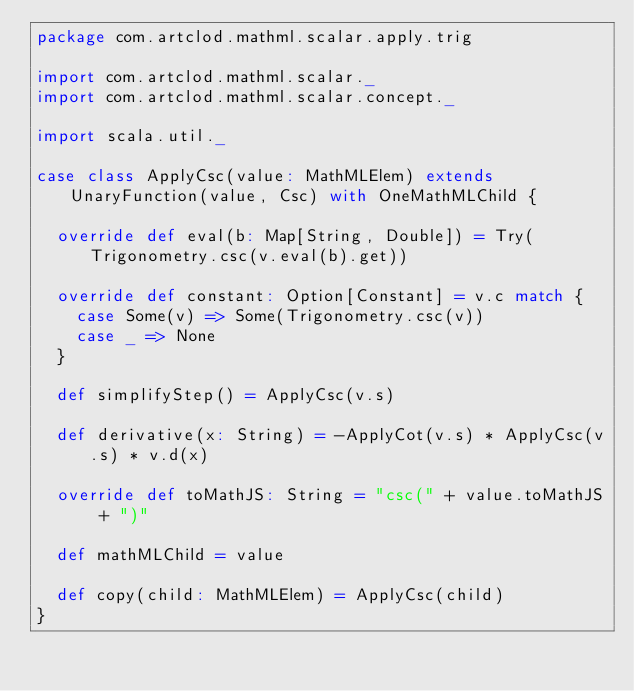Convert code to text. <code><loc_0><loc_0><loc_500><loc_500><_Scala_>package com.artclod.mathml.scalar.apply.trig

import com.artclod.mathml.scalar._
import com.artclod.mathml.scalar.concept._

import scala.util._

case class ApplyCsc(value: MathMLElem) extends UnaryFunction(value, Csc) with OneMathMLChild {

	override def eval(b: Map[String, Double]) = Try(Trigonometry.csc(v.eval(b).get))

	override def constant: Option[Constant] = v.c match {
		case Some(v) => Some(Trigonometry.csc(v))
		case _ => None
	}

	def simplifyStep() = ApplyCsc(v.s)

	def derivative(x: String) = -ApplyCot(v.s) * ApplyCsc(v.s) * v.d(x)

	override def toMathJS: String = "csc(" + value.toMathJS + ")"

	def mathMLChild = value

	def copy(child: MathMLElem) = ApplyCsc(child)
}</code> 